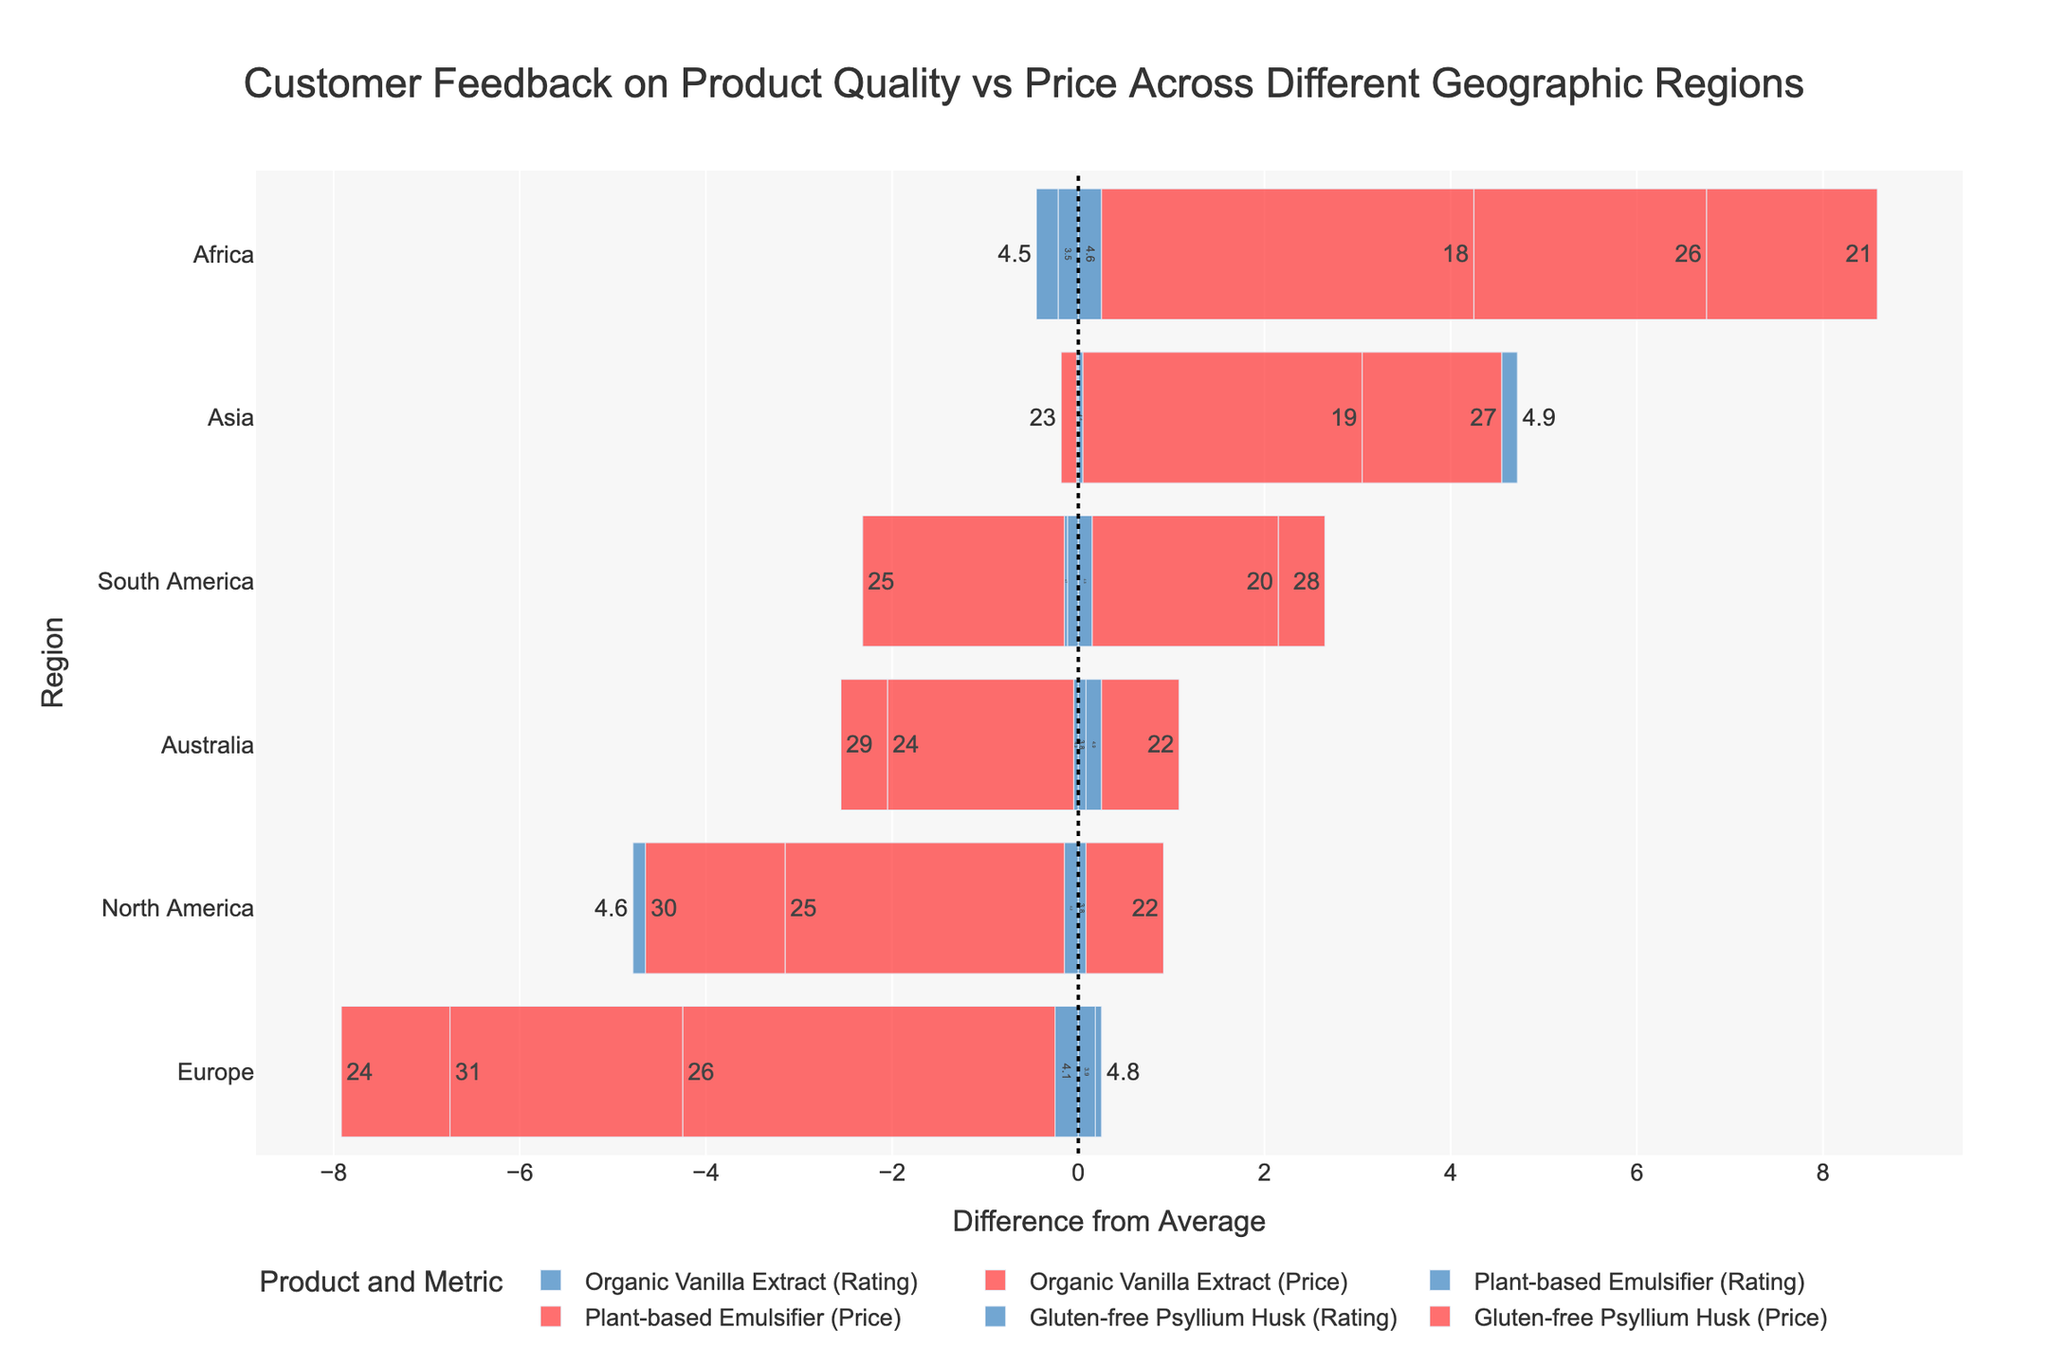Which product has the highest positive rating difference in Europe? The chart shows the rating differences for each product by region, represented by bars. We look for the longest blue bar in Europe pointing to the right. "Gluten-free Psyllium Husk" has the highest positive rating difference in Europe.
Answer: Gluten-free Psyllium Husk What is the average rating and price difference for Organic Vanilla Extract in North America and Asia? First, find the blue bar representing the rating difference for Organic Vanilla Extract in North America and Asia. Sum these differences and divide by the number of regions (2). Then, do the same for the red bar representing the price difference. The blue bars show differences of -0.3 and +0.0 for ratings. The red bars show differences of +3.5 and -2.5 for prices. Average rating difference = (-0.3 + 0)/2 = -0.15. Average price difference = (3.5 - 2.5)/2 = 0.5.
Answer: Average rating difference: -0.15, Average price difference: 0.5 Which region shows the largest negative price difference for Plant-based Emulsifier? The chart shows the price differences in red bars. We identify the longest red bar pointing to the left for Plant-based Emulsifier. In this case, Africa has the largest negative price difference for this product.
Answer: Africa How does the rating difference of the Gluten-free Psyllium Husk in South America compare to Australia? Look at the blue bars for Gluten-free Psyllium Husk in both regions. The bar in South America points slightly to the right and is smaller than Australia. Thus, compared to Australia, the rating difference in South America is smaller.
Answer: Smaller in South America What color represents the price difference? Identify the color of the bars indicating price differences. The red bars represent the price difference for each product.
Answer: Red How does North America's price and rating difference for Organic Vanilla Extract compare overall? Examine both the red and blue bars for Organic Vanilla Extract in North America. The red bar (price difference) is quite large to the right, indicating a positive difference, and the blue bar (rating difference) is slightly to the left, indicating a negative difference.
Answer: Positive price difference, negative rating difference Which product and region pair shows the largest positive rating difference? Identify the longest blue bar on the chart pointing to the right, regardless of the product or region. "Gluten-free Psyllium Husk" in Asia has the largest positive rating difference.
Answer: Gluten-free Psyllium Husk in Asia What is the rating difference range for Plant-based Emulsifier in all regions? Look at the blue bars for Plant-based Emulsifier across all regions. Identify the smallest and largest values. Range is [-0.4 (Africa) to +0.1 (Europe)].
Answer: -0.4 to +0.1 